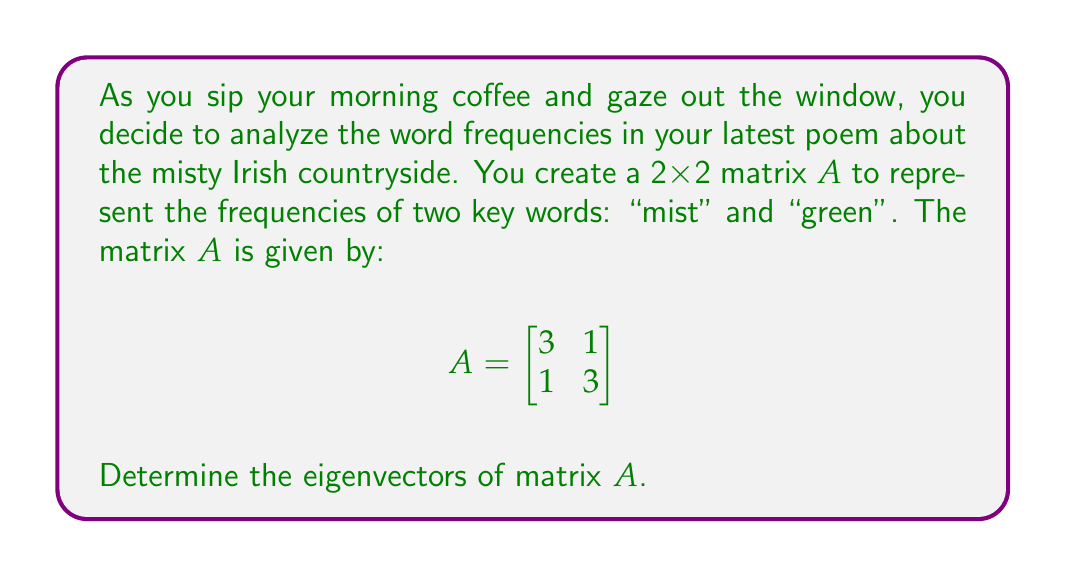What is the answer to this math problem? To find the eigenvectors of matrix A, we follow these steps:

1) First, we need to find the eigenvalues by solving the characteristic equation:
   $$det(A - \lambda I) = 0$$

2) Expanding this:
   $$\begin{vmatrix}
   3-\lambda & 1 \\
   1 & 3-\lambda
   \end{vmatrix} = 0$$

3) $(3-\lambda)^2 - 1 = 0$
   $9 - 6\lambda + \lambda^2 - 1 = 0$
   $\lambda^2 - 6\lambda + 8 = 0$

4) Solving this quadratic equation:
   $(\lambda - 4)(\lambda - 2) = 0$
   So, $\lambda_1 = 4$ and $\lambda_2 = 2$

5) For $\lambda_1 = 4$, we solve $(A - 4I)v = 0$:
   $$\begin{bmatrix}
   -1 & 1 \\
   1 & -1
   \end{bmatrix}\begin{bmatrix}
   v_1 \\
   v_2
   \end{bmatrix} = \begin{bmatrix}
   0 \\
   0
   \end{bmatrix}$$

   This gives us: $v_1 = v_2$. We can choose $v_1 = v_2 = 1$.

6) For $\lambda_2 = 2$, we solve $(A - 2I)v = 0$:
   $$\begin{bmatrix}
   1 & 1 \\
   1 & 1
   \end{bmatrix}\begin{bmatrix}
   v_1 \\
   v_2
   \end{bmatrix} = \begin{bmatrix}
   0 \\
   0
   \end{bmatrix}$$

   This gives us: $v_1 = -v_2$. We can choose $v_1 = 1, v_2 = -1$.

Therefore, the eigenvectors are $\begin{bmatrix} 1 \\ 1 \end{bmatrix}$ and $\begin{bmatrix} 1 \\ -1 \end{bmatrix}$.
Answer: $\begin{bmatrix} 1 \\ 1 \end{bmatrix}$ and $\begin{bmatrix} 1 \\ -1 \end{bmatrix}$ 